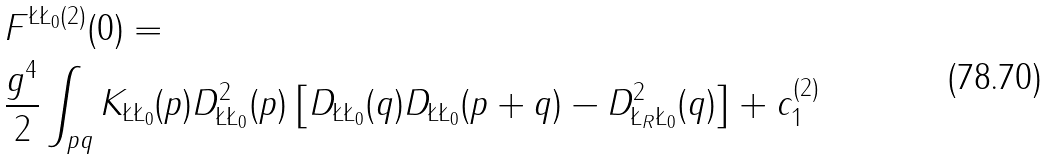<formula> <loc_0><loc_0><loc_500><loc_500>& F ^ { \L \L _ { 0 } ( 2 ) } ( 0 ) = \\ & \frac { g ^ { 4 } } { 2 } \int _ { p q } K _ { \L \L _ { 0 } } ( p ) D ^ { 2 } _ { \L \L _ { 0 } } ( p ) \left [ D _ { \L \L _ { 0 } } ( q ) D _ { \L \L _ { 0 } } ( p + q ) - D _ { \L _ { R } \L _ { 0 } } ^ { 2 } ( q ) \right ] + c _ { 1 } ^ { ( 2 ) }</formula> 